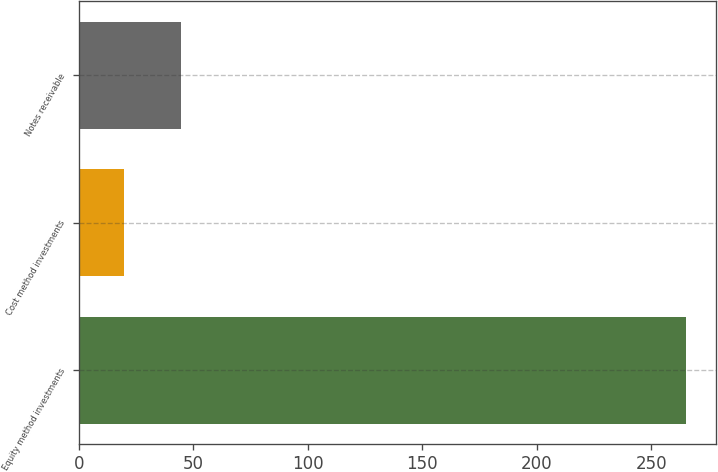<chart> <loc_0><loc_0><loc_500><loc_500><bar_chart><fcel>Equity method investments<fcel>Cost method investments<fcel>Notes receivable<nl><fcel>265<fcel>20<fcel>44.5<nl></chart> 